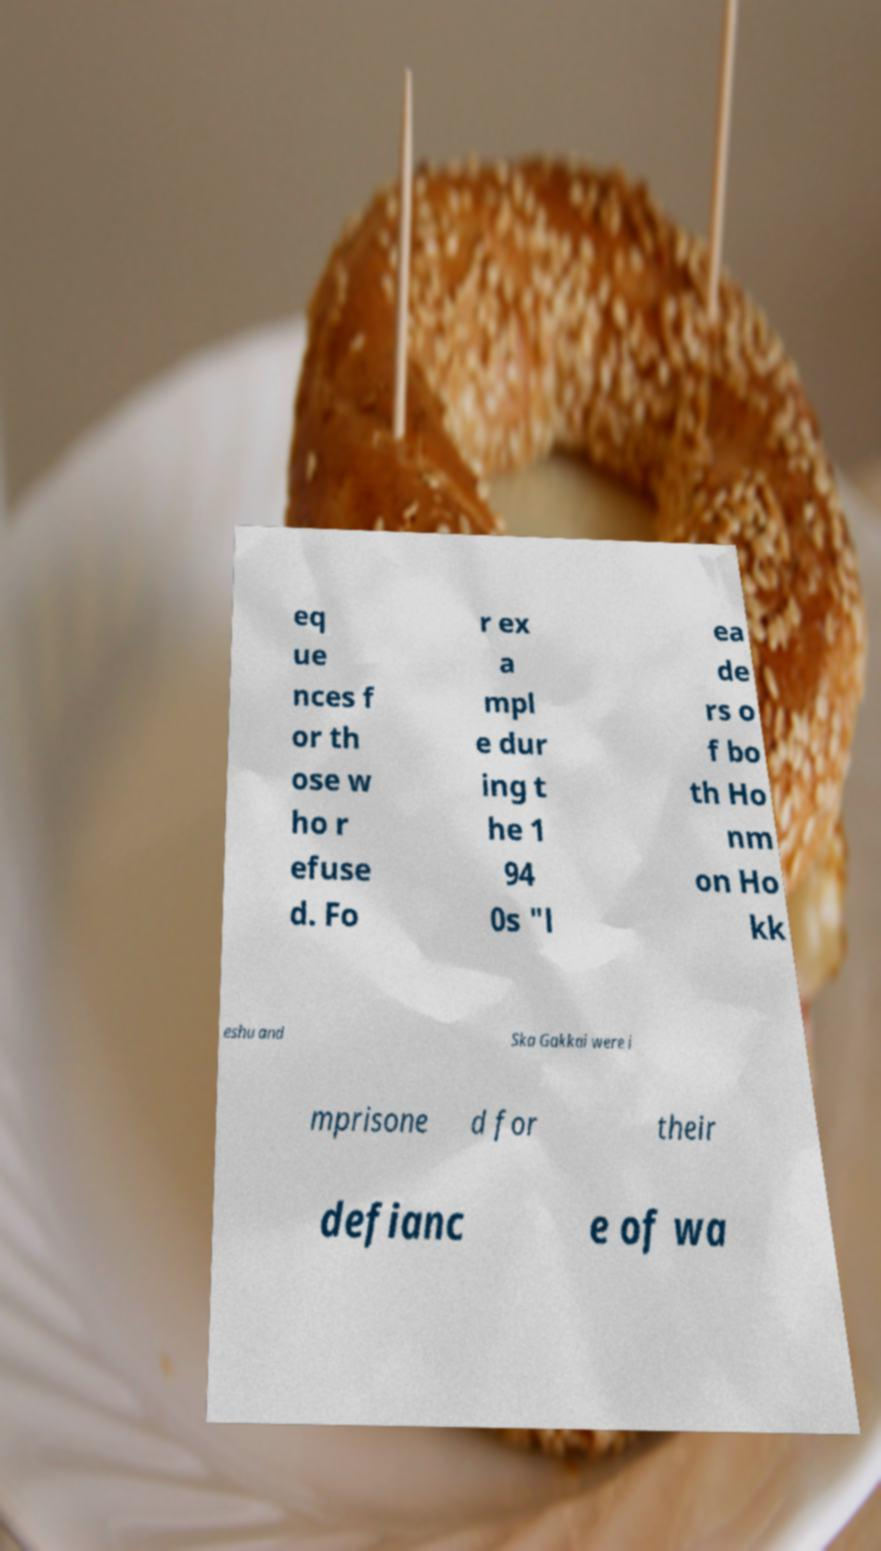Can you accurately transcribe the text from the provided image for me? eq ue nces f or th ose w ho r efuse d. Fo r ex a mpl e dur ing t he 1 94 0s "l ea de rs o f bo th Ho nm on Ho kk eshu and Ska Gakkai were i mprisone d for their defianc e of wa 